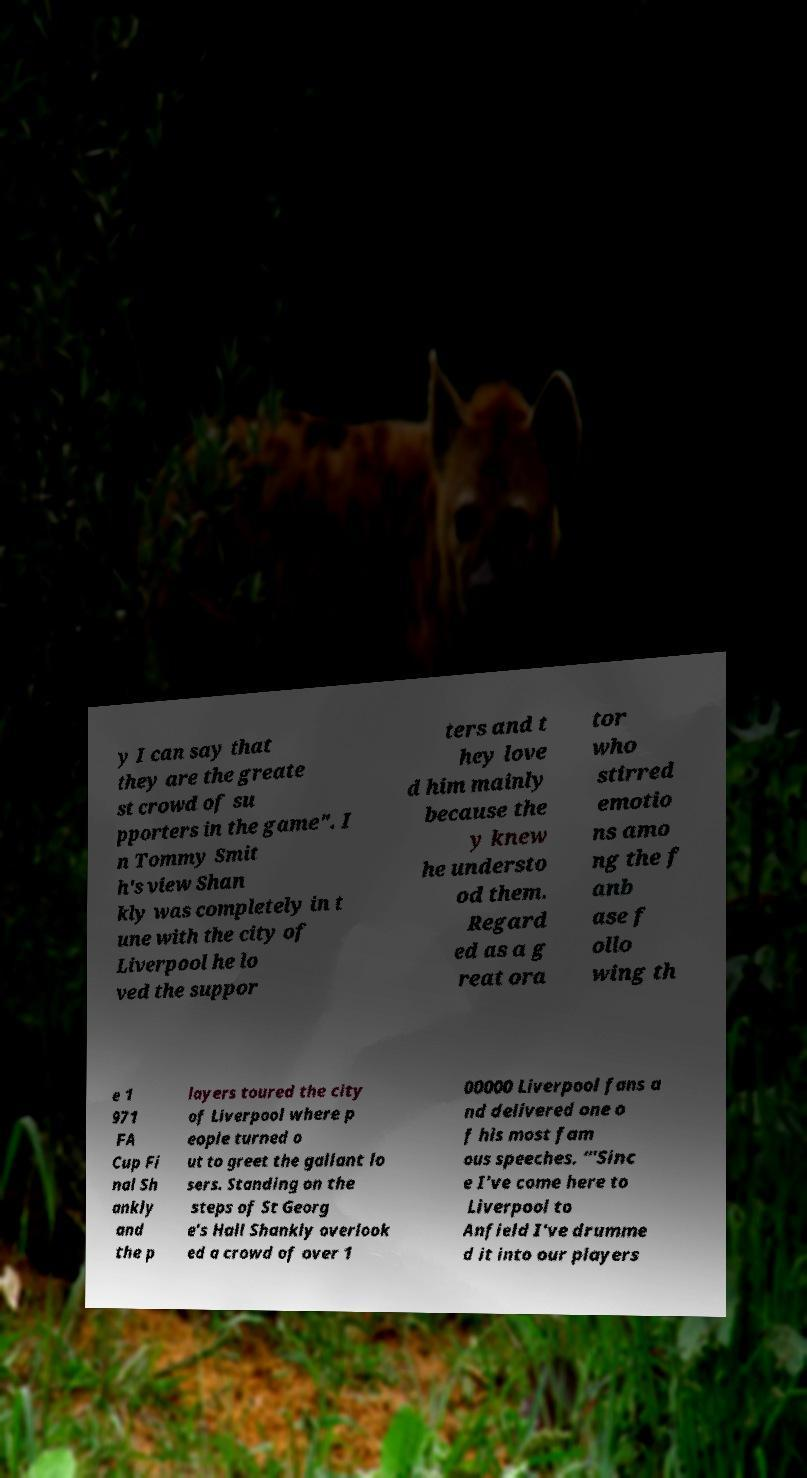I need the written content from this picture converted into text. Can you do that? y I can say that they are the greate st crowd of su pporters in the game". I n Tommy Smit h's view Shan kly was completely in t une with the city of Liverpool he lo ved the suppor ters and t hey love d him mainly because the y knew he understo od them. Regard ed as a g reat ora tor who stirred emotio ns amo ng the f anb ase f ollo wing th e 1 971 FA Cup Fi nal Sh ankly and the p layers toured the city of Liverpool where p eople turned o ut to greet the gallant lo sers. Standing on the steps of St Georg e's Hall Shankly overlook ed a crowd of over 1 00000 Liverpool fans a nd delivered one o f his most fam ous speeches. “'Sinc e I've come here to Liverpool to Anfield I've drumme d it into our players 